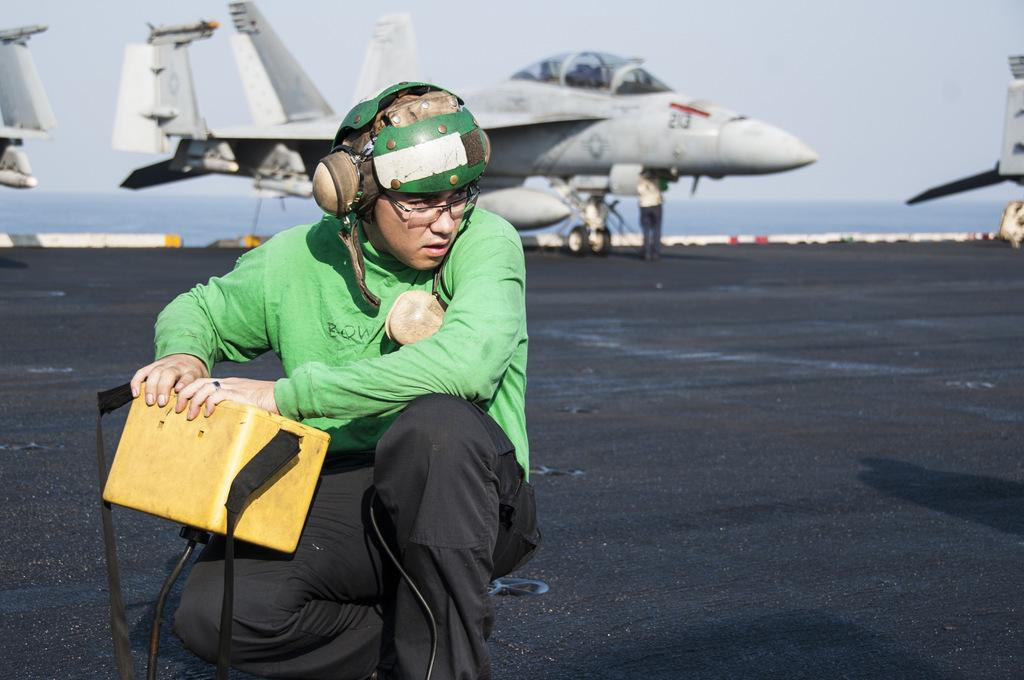What is the person in the image holding? The person is holding a box in the image. What can be seen in the background of the image? Jet planes and water are visible in the background. What is visible at the top of the image? The sky is visible at the top of the image. What type of muscle is visible on the person's face in the image? There is no muscle visible on the person's face in the image, as faces do not have muscles. What kind of jewel is the person wearing in the image? There is no jewel visible on the person in the image. 